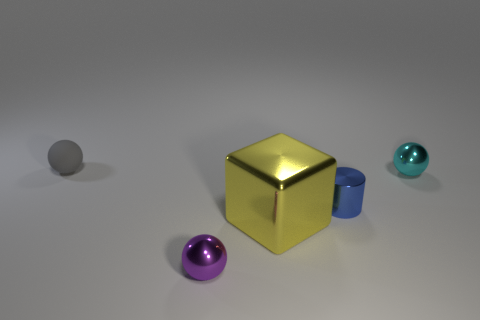Subtract all small metal balls. How many balls are left? 1 Add 2 tiny blue cylinders. How many objects exist? 7 Subtract all cyan spheres. How many spheres are left? 2 Subtract 1 cylinders. How many cylinders are left? 0 Add 3 purple balls. How many purple balls exist? 4 Subtract 0 gray cylinders. How many objects are left? 5 Subtract all spheres. How many objects are left? 2 Subtract all red blocks. Subtract all brown spheres. How many blocks are left? 1 Subtract all big rubber blocks. Subtract all tiny gray spheres. How many objects are left? 4 Add 4 spheres. How many spheres are left? 7 